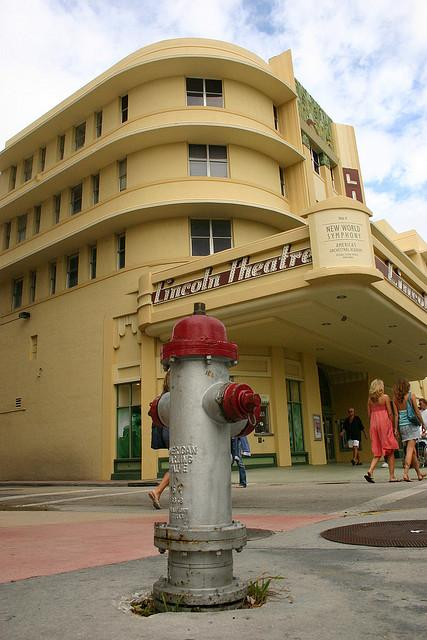What could someone do inside the yellow building?

Choices:
A) mail letters
B) buy clothing
C) watch movie
D) exercise watch movie 